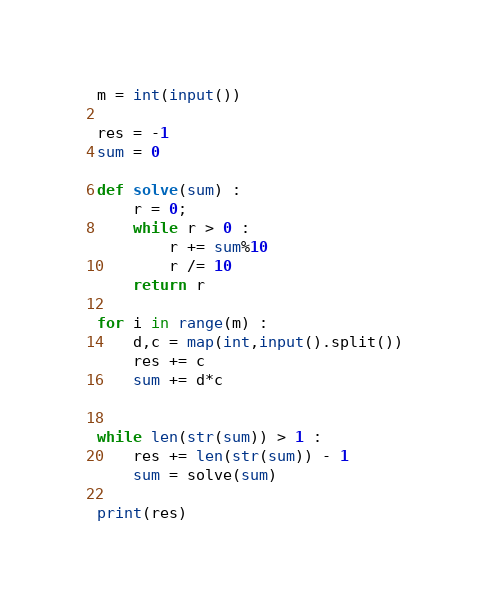Convert code to text. <code><loc_0><loc_0><loc_500><loc_500><_Python_>
m = int(input())

res = -1
sum = 0

def solve(sum) :
    r = 0;
    while r > 0 :
        r += sum%10
        r /= 10
    return r

for i in range(m) :
    d,c = map(int,input().split())
    res += c
    sum += d*c


while len(str(sum)) > 1 :
    res += len(str(sum)) - 1
    sum = solve(sum)

print(res)</code> 